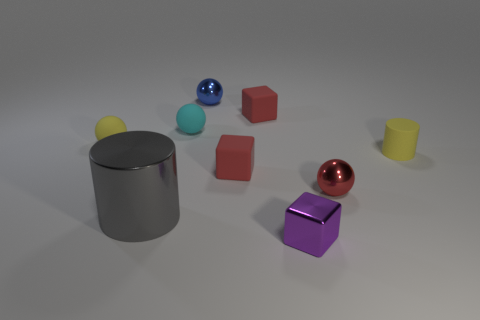Subtract all small red spheres. How many spheres are left? 3 Add 1 tiny purple cubes. How many objects exist? 10 Subtract 2 cylinders. How many cylinders are left? 0 Subtract all cyan balls. How many balls are left? 3 Subtract 0 green cylinders. How many objects are left? 9 Subtract all cylinders. How many objects are left? 7 Subtract all cyan cylinders. Subtract all cyan cubes. How many cylinders are left? 2 Subtract all purple blocks. How many brown cylinders are left? 0 Subtract all small purple shiny blocks. Subtract all small yellow matte cylinders. How many objects are left? 7 Add 7 small purple metallic blocks. How many small purple metallic blocks are left? 8 